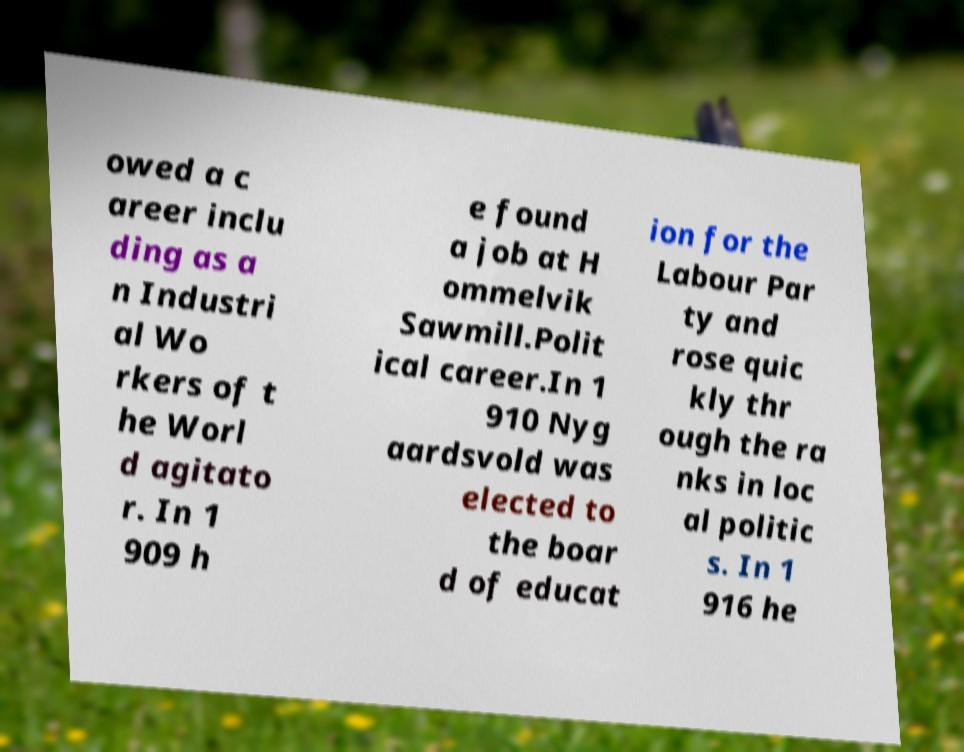There's text embedded in this image that I need extracted. Can you transcribe it verbatim? owed a c areer inclu ding as a n Industri al Wo rkers of t he Worl d agitato r. In 1 909 h e found a job at H ommelvik Sawmill.Polit ical career.In 1 910 Nyg aardsvold was elected to the boar d of educat ion for the Labour Par ty and rose quic kly thr ough the ra nks in loc al politic s. In 1 916 he 